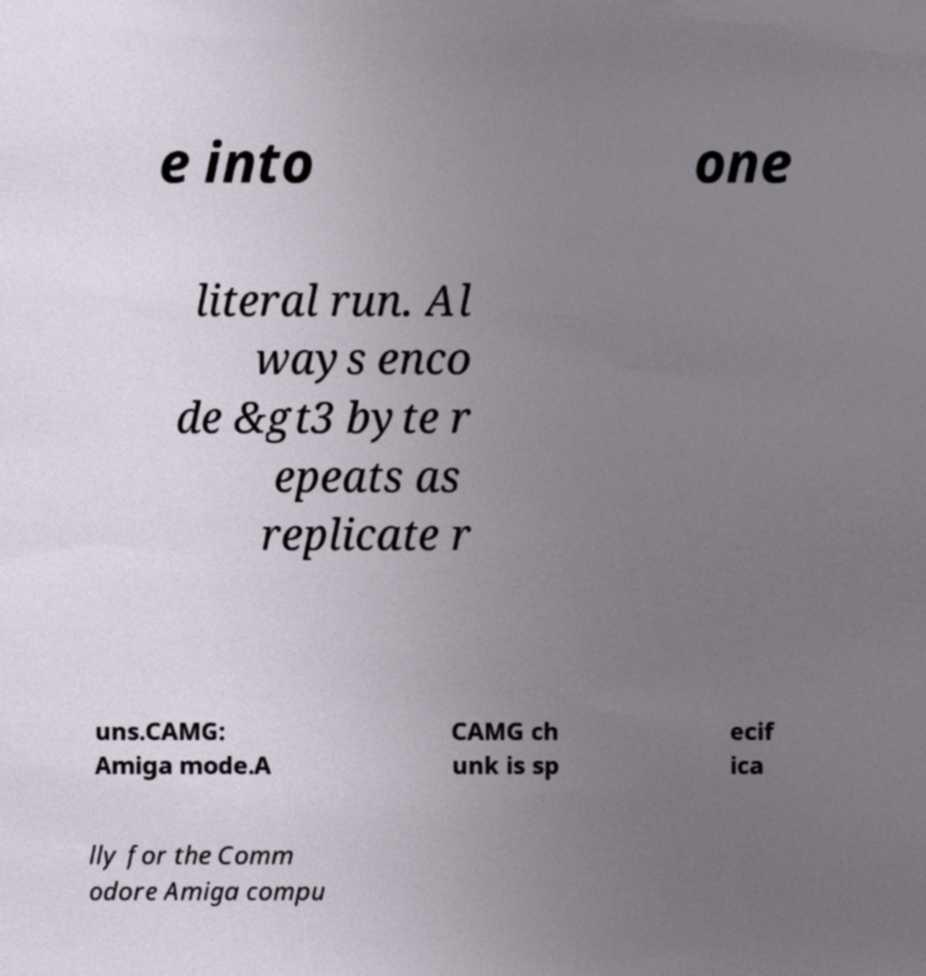I need the written content from this picture converted into text. Can you do that? e into one literal run. Al ways enco de &gt3 byte r epeats as replicate r uns.CAMG: Amiga mode.A CAMG ch unk is sp ecif ica lly for the Comm odore Amiga compu 